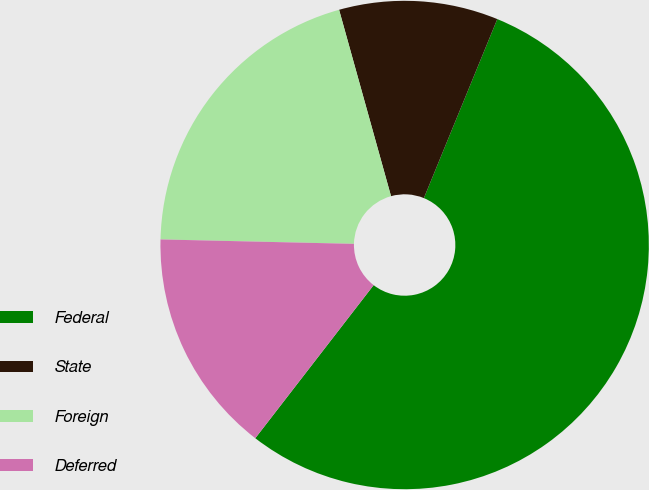Convert chart to OTSL. <chart><loc_0><loc_0><loc_500><loc_500><pie_chart><fcel>Federal<fcel>State<fcel>Foreign<fcel>Deferred<nl><fcel>54.28%<fcel>10.52%<fcel>20.31%<fcel>14.89%<nl></chart> 